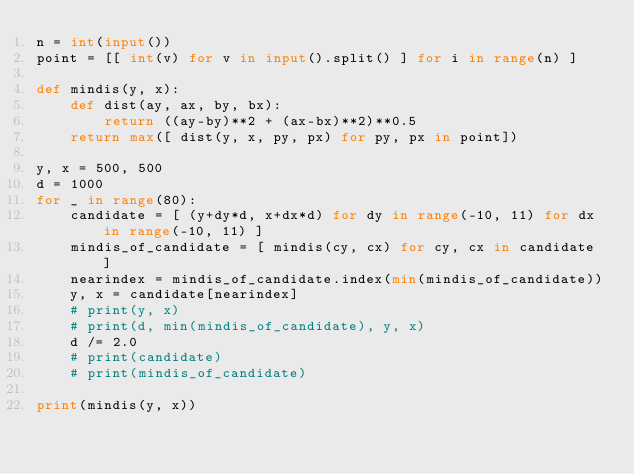Convert code to text. <code><loc_0><loc_0><loc_500><loc_500><_Python_>n = int(input())
point = [[ int(v) for v in input().split() ] for i in range(n) ]

def mindis(y, x):
    def dist(ay, ax, by, bx):
        return ((ay-by)**2 + (ax-bx)**2)**0.5
    return max([ dist(y, x, py, px) for py, px in point])

y, x = 500, 500
d = 1000
for _ in range(80):
    candidate = [ (y+dy*d, x+dx*d) for dy in range(-10, 11) for dx in range(-10, 11) ]
    mindis_of_candidate = [ mindis(cy, cx) for cy, cx in candidate ]
    nearindex = mindis_of_candidate.index(min(mindis_of_candidate))
    y, x = candidate[nearindex]
    # print(y, x)
    # print(d, min(mindis_of_candidate), y, x)
    d /= 2.0
    # print(candidate)
    # print(mindis_of_candidate)

print(mindis(y, x))</code> 